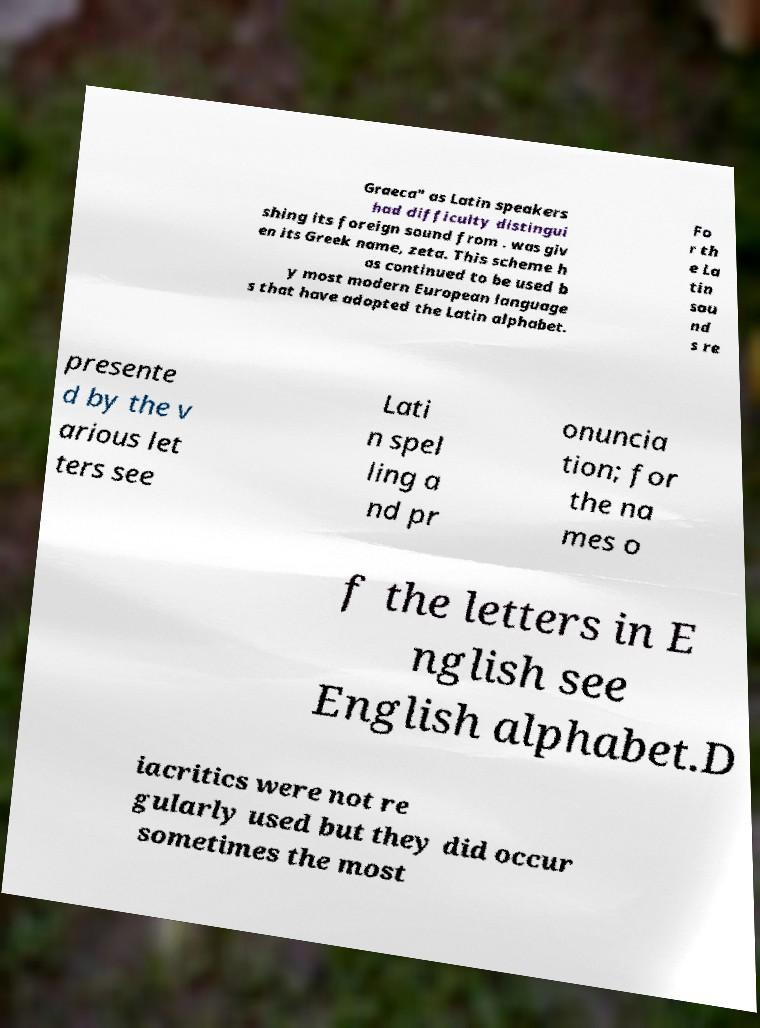Please identify and transcribe the text found in this image. Graeca" as Latin speakers had difficulty distingui shing its foreign sound from . was giv en its Greek name, zeta. This scheme h as continued to be used b y most modern European language s that have adopted the Latin alphabet. Fo r th e La tin sou nd s re presente d by the v arious let ters see Lati n spel ling a nd pr onuncia tion; for the na mes o f the letters in E nglish see English alphabet.D iacritics were not re gularly used but they did occur sometimes the most 